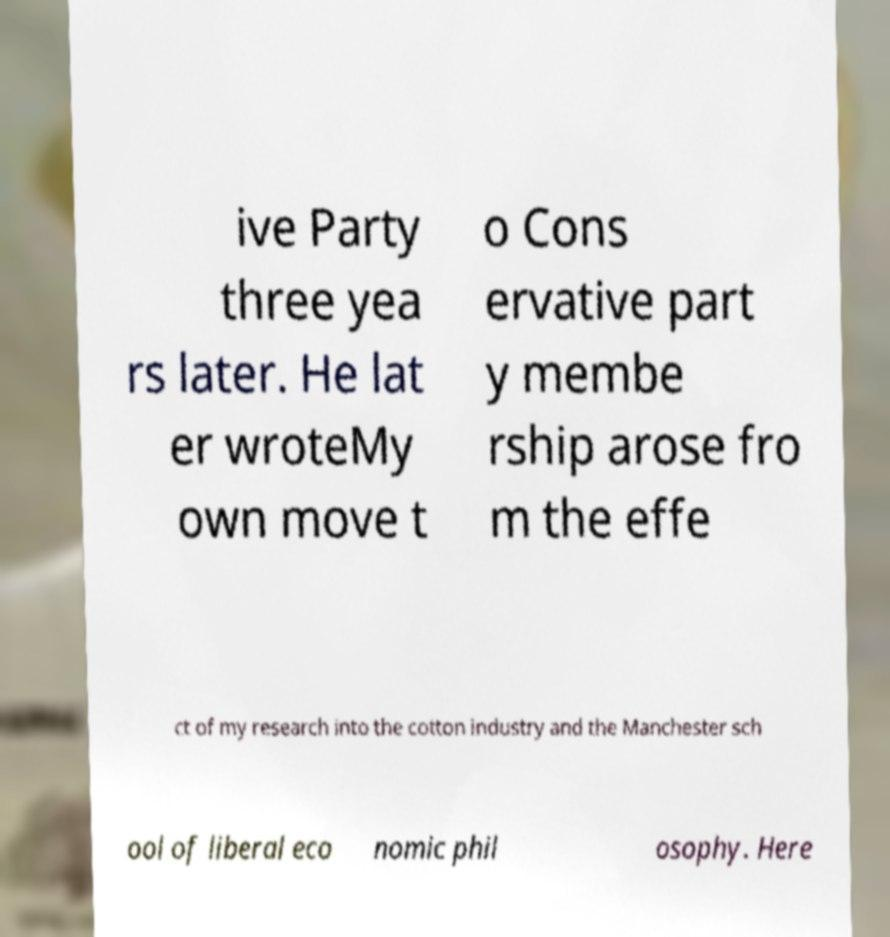Could you extract and type out the text from this image? ive Party three yea rs later. He lat er wroteMy own move t o Cons ervative part y membe rship arose fro m the effe ct of my research into the cotton industry and the Manchester sch ool of liberal eco nomic phil osophy. Here 